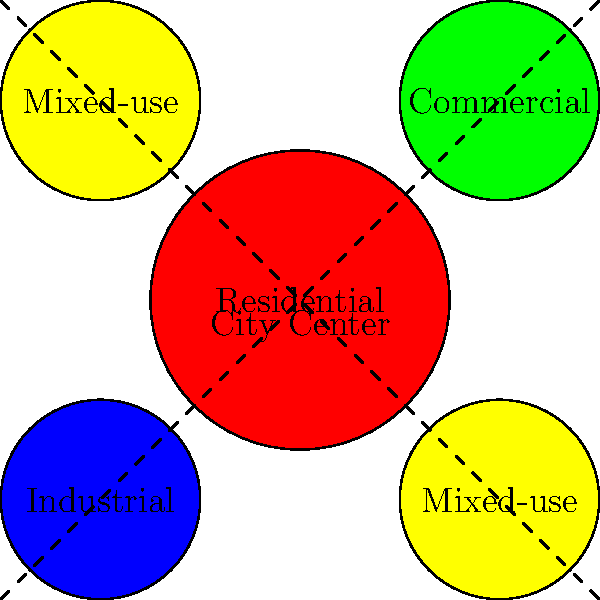Analyze the city map provided, which shows different zoning areas. How might this urban planning approach impact community integration, and what potential modifications could enhance social cohesion across diverse neighborhoods? To answer this question, we need to consider several factors:

1. Zoning distribution:
   - The map shows a central residential area surrounded by commercial, industrial, and mixed-use zones.
   - Mixed-use areas are present in two corners, potentially serving as transition zones.

2. Impact on community integration:
   a) Segregation: The clear separation of zones might lead to reduced interaction between different socioeconomic groups.
   b) Commuting patterns: Residents may need to travel to work in industrial or commercial areas, potentially creating traffic issues.
   c) Access to services: The central location of the residential area might provide easy access to various services.

3. Potential improvements for social cohesion:
   a) Increase mixed-use zones: Expanding mixed-use areas can promote diverse interactions and reduce segregation.
   b) Create community spaces: Introduce parks, community centers, or public squares at zone intersections to encourage mingling.
   c) Implement inclusive housing policies: Ensure a mix of housing types and price ranges in residential areas to promote socioeconomic diversity.
   d) Improve public transportation: Enhance connectivity between zones to facilitate movement and interaction.
   e) Encourage participatory planning: Involve residents from all zones in decision-making processes to foster a sense of shared community.

4. Considerations for diverse perspectives:
   - Recognize that different cultural groups may have varying needs and preferences in urban spaces.
   - Consider the historical context of zoning and its potential role in perpetuating inequalities.
   - Evaluate the impact of zoning on marginalized communities and seek to address any disparities.

By implementing these strategies, the urban planning approach can evolve to better support community integration and social cohesion across diverse neighborhoods.
Answer: Increase mixed-use zones, create inclusive community spaces, and implement participatory planning to enhance social cohesion. 